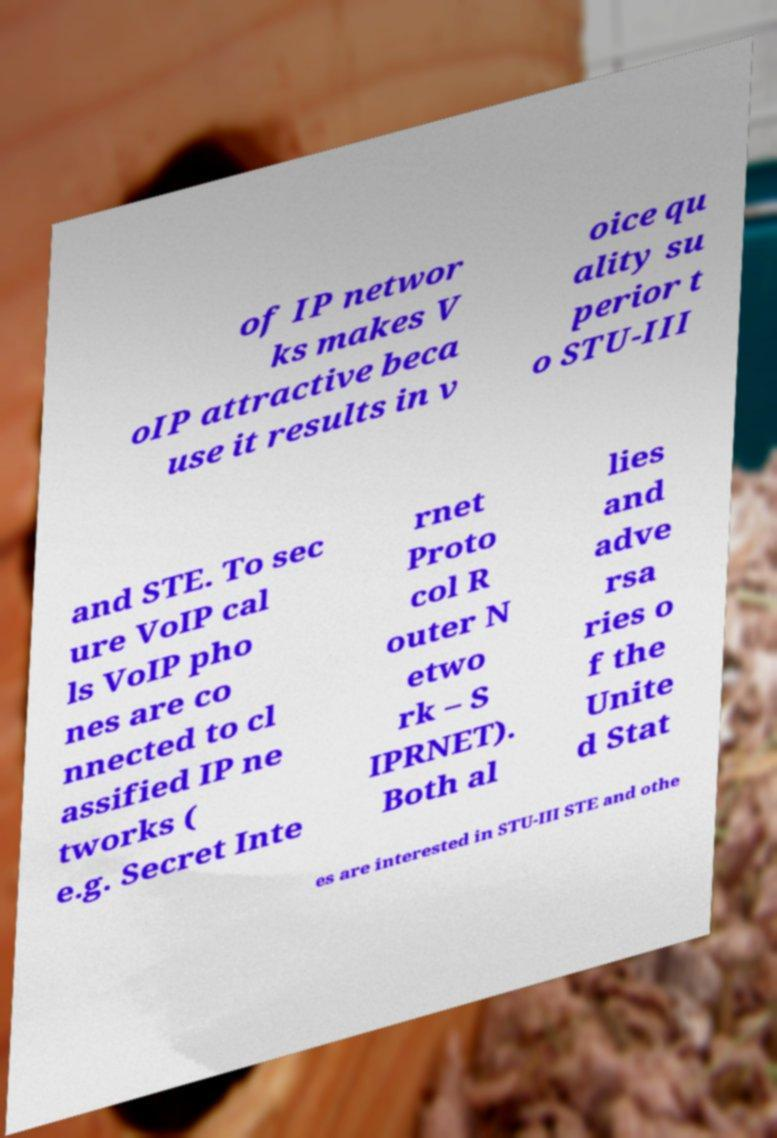Please identify and transcribe the text found in this image. of IP networ ks makes V oIP attractive beca use it results in v oice qu ality su perior t o STU-III and STE. To sec ure VoIP cal ls VoIP pho nes are co nnected to cl assified IP ne tworks ( e.g. Secret Inte rnet Proto col R outer N etwo rk – S IPRNET). Both al lies and adve rsa ries o f the Unite d Stat es are interested in STU-III STE and othe 